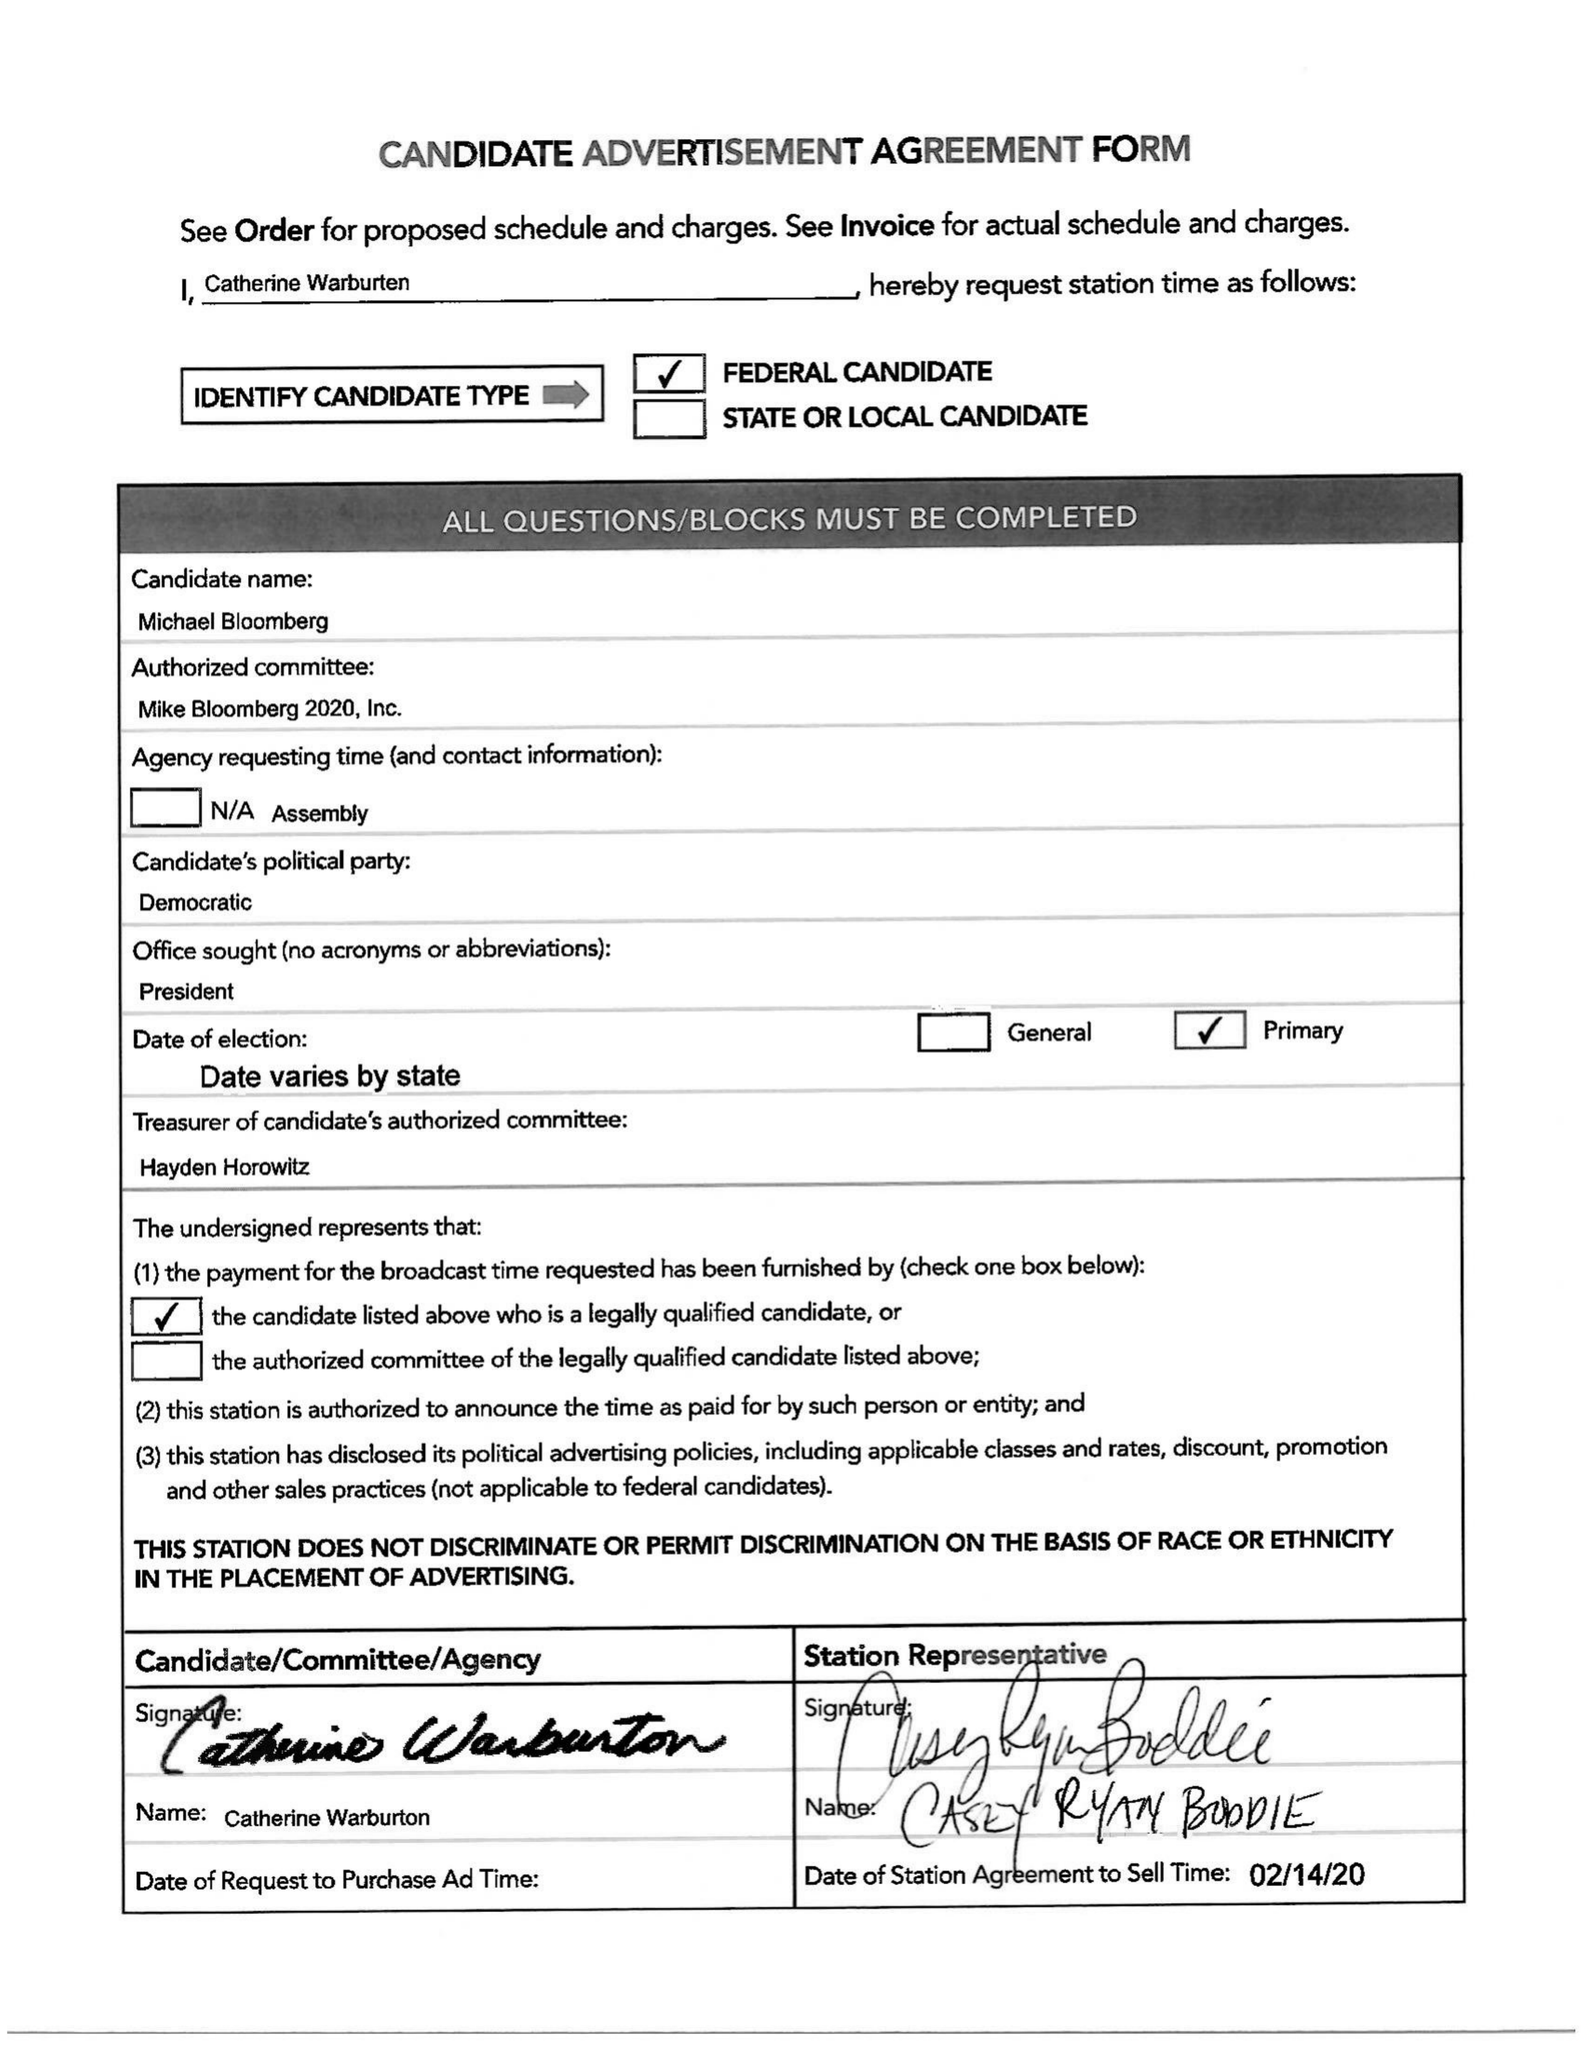What is the value for the contract_num?
Answer the question using a single word or phrase. 2383706 